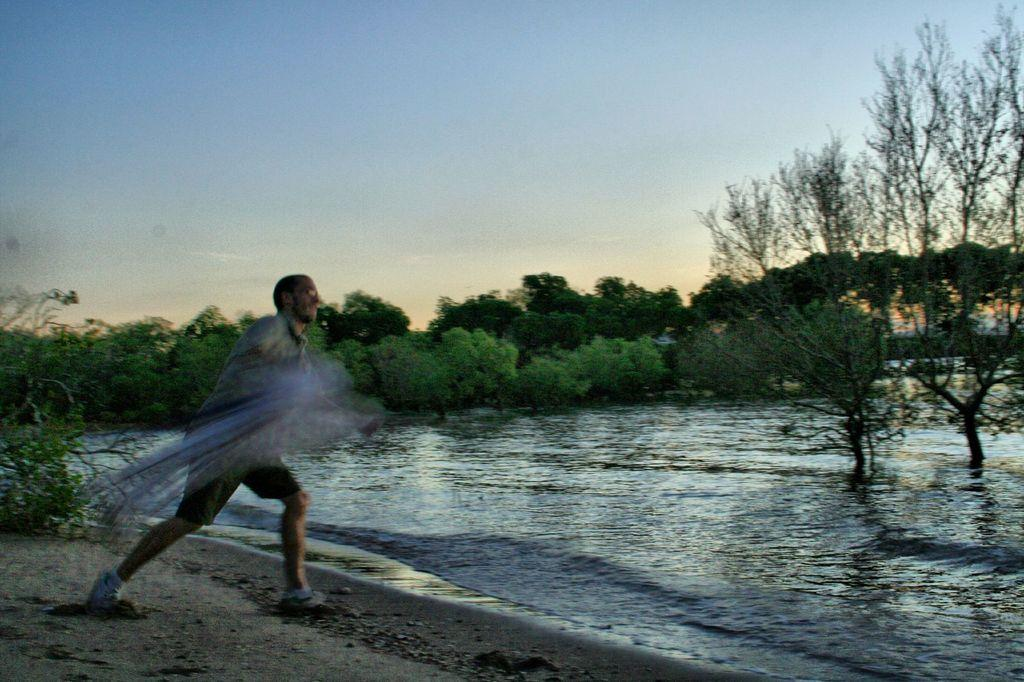What is the man in the image doing? The man is standing in the image and holding a net. What can be seen in the background of the image? There are trees visible in the background of the image. What is visible at the top of the image? The sky is visible at the top of the image. What is visible at the bottom of the image? There is water and ground visible at the bottom of the image. What type of produce is being served at the feast in the image? There is no feast present in the image, so it is not possible to determine what type of produce might be served. 